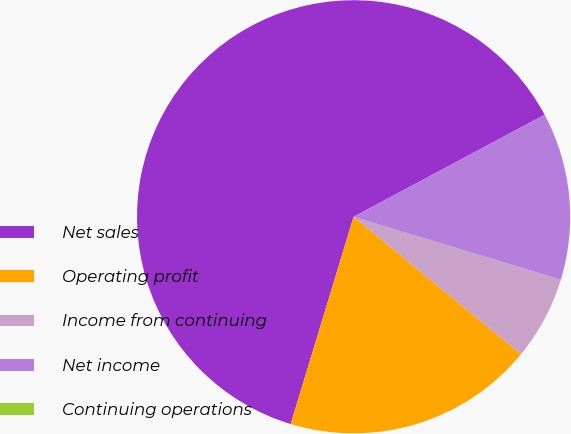Convert chart to OTSL. <chart><loc_0><loc_0><loc_500><loc_500><pie_chart><fcel>Net sales<fcel>Operating profit<fcel>Income from continuing<fcel>Net income<fcel>Continuing operations<nl><fcel>62.5%<fcel>18.75%<fcel>6.25%<fcel>12.5%<fcel>0.0%<nl></chart> 